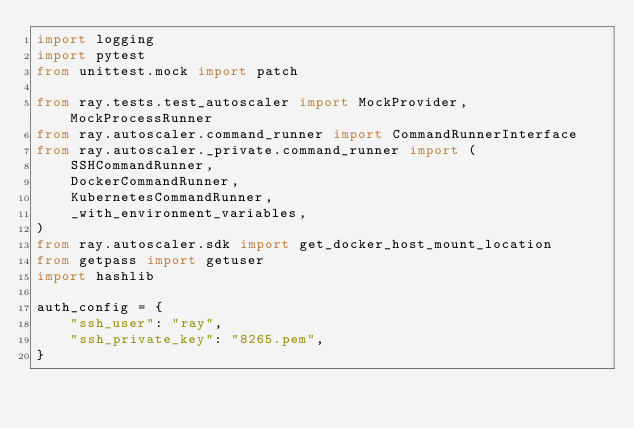Convert code to text. <code><loc_0><loc_0><loc_500><loc_500><_Python_>import logging
import pytest
from unittest.mock import patch

from ray.tests.test_autoscaler import MockProvider, MockProcessRunner
from ray.autoscaler.command_runner import CommandRunnerInterface
from ray.autoscaler._private.command_runner import (
    SSHCommandRunner,
    DockerCommandRunner,
    KubernetesCommandRunner,
    _with_environment_variables,
)
from ray.autoscaler.sdk import get_docker_host_mount_location
from getpass import getuser
import hashlib

auth_config = {
    "ssh_user": "ray",
    "ssh_private_key": "8265.pem",
}

</code> 